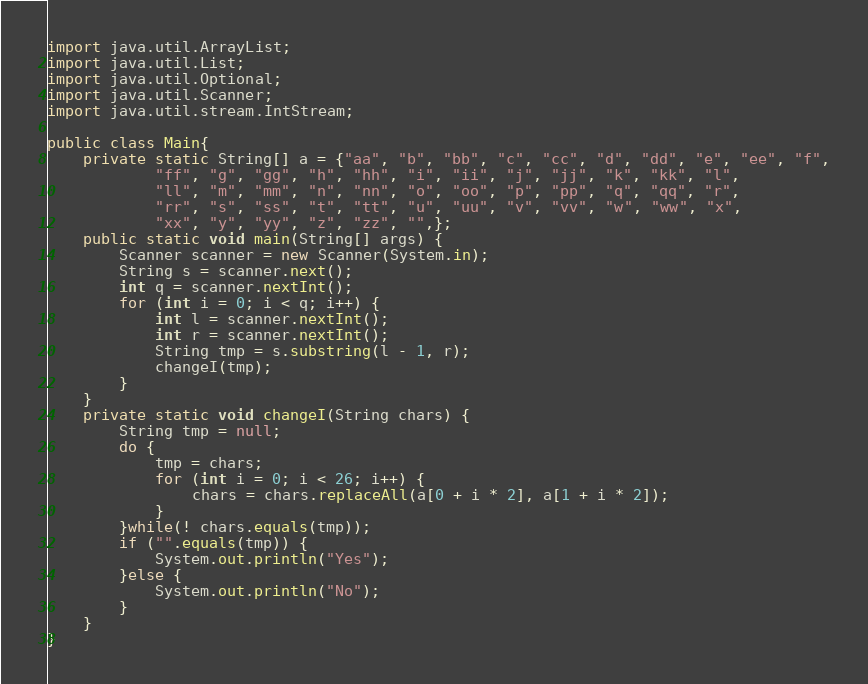<code> <loc_0><loc_0><loc_500><loc_500><_Java_>import java.util.ArrayList;
import java.util.List;
import java.util.Optional;
import java.util.Scanner;
import java.util.stream.IntStream;

public class Main{
	private static String[] a = {"aa", "b", "bb", "c", "cc", "d", "dd", "e", "ee", "f",
			"ff", "g", "gg", "h", "hh", "i", "ii", "j", "jj", "k", "kk", "l",
			"ll", "m", "mm", "n", "nn", "o", "oo", "p", "pp", "q", "qq", "r",
			"rr", "s", "ss", "t", "tt", "u", "uu", "v", "vv", "w", "ww", "x",
			"xx", "y", "yy", "z", "zz", "",};
	public static void main(String[] args) {
		Scanner scanner = new Scanner(System.in);
		String s = scanner.next();
		int q = scanner.nextInt();
		for (int i = 0; i < q; i++) {
			int l = scanner.nextInt();
			int r = scanner.nextInt();
			String tmp = s.substring(l - 1, r);
			changeI(tmp);
		}
	}
	private static void changeI(String chars) {
		String tmp = null;
		do {
			tmp = chars;
			for (int i = 0; i < 26; i++) {
				chars = chars.replaceAll(a[0 + i * 2], a[1 + i * 2]);
			}
		}while(! chars.equals(tmp));
		if ("".equals(tmp)) {
			System.out.println("Yes");
		}else {
			System.out.println("No");
		}
	}
}
</code> 